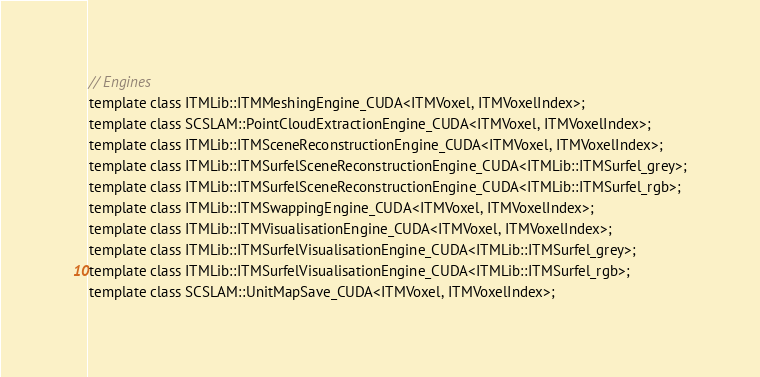Convert code to text. <code><loc_0><loc_0><loc_500><loc_500><_Cuda_>
// Engines
template class ITMLib::ITMMeshingEngine_CUDA<ITMVoxel, ITMVoxelIndex>;
template class SCSLAM::PointCloudExtractionEngine_CUDA<ITMVoxel, ITMVoxelIndex>;
template class ITMLib::ITMSceneReconstructionEngine_CUDA<ITMVoxel, ITMVoxelIndex>;
template class ITMLib::ITMSurfelSceneReconstructionEngine_CUDA<ITMLib::ITMSurfel_grey>;
template class ITMLib::ITMSurfelSceneReconstructionEngine_CUDA<ITMLib::ITMSurfel_rgb>;
template class ITMLib::ITMSwappingEngine_CUDA<ITMVoxel, ITMVoxelIndex>;
template class ITMLib::ITMVisualisationEngine_CUDA<ITMVoxel, ITMVoxelIndex>;
template class ITMLib::ITMSurfelVisualisationEngine_CUDA<ITMLib::ITMSurfel_grey>;
template class ITMLib::ITMSurfelVisualisationEngine_CUDA<ITMLib::ITMSurfel_rgb>;
template class SCSLAM::UnitMapSave_CUDA<ITMVoxel, ITMVoxelIndex>;
</code> 